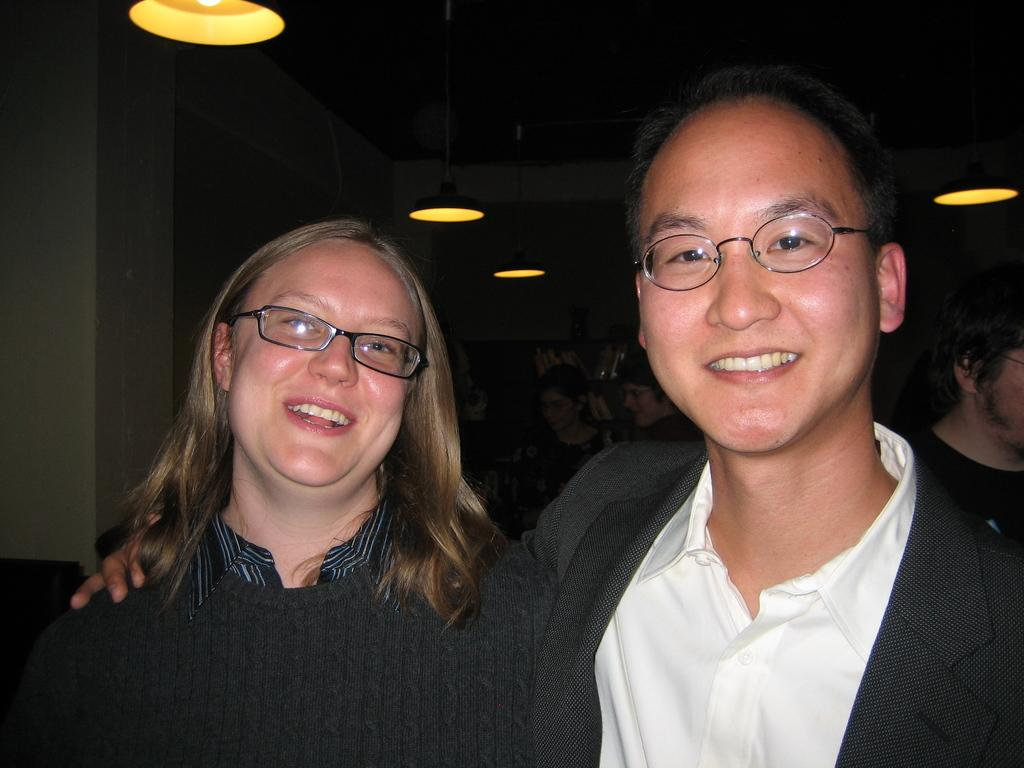Who are the people in the image? There is a man and a woman in the image. What are they both wearing? Both the man and woman are wearing glasses. What can be seen at the top of the image? There are lights visible at the top of the image. How does the sofa in the image shake when the man and woman sit on it? There is no sofa present in the image, so it cannot shake or be sat upon. 